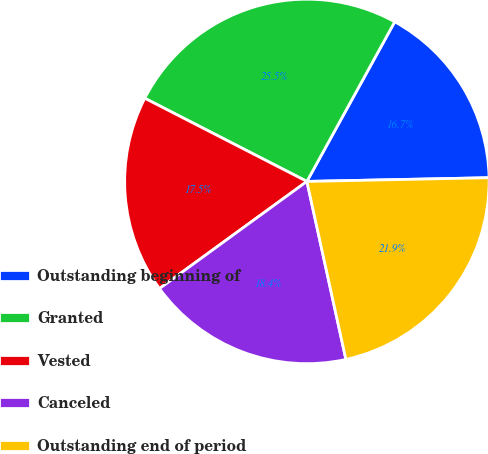<chart> <loc_0><loc_0><loc_500><loc_500><pie_chart><fcel>Outstanding beginning of<fcel>Granted<fcel>Vested<fcel>Canceled<fcel>Outstanding end of period<nl><fcel>16.67%<fcel>25.46%<fcel>17.55%<fcel>18.43%<fcel>21.89%<nl></chart> 